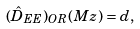<formula> <loc_0><loc_0><loc_500><loc_500>( \hat { D } _ { E E } ) _ { O R } ( M z ) = d ,</formula> 